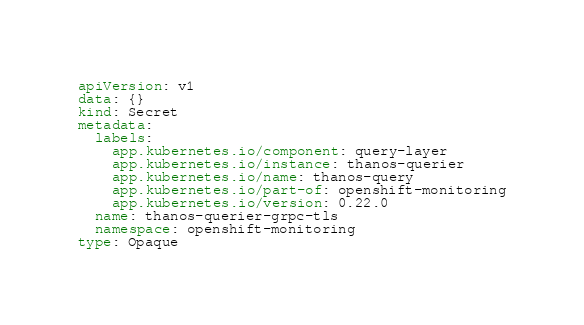<code> <loc_0><loc_0><loc_500><loc_500><_YAML_>apiVersion: v1
data: {}
kind: Secret
metadata:
  labels:
    app.kubernetes.io/component: query-layer
    app.kubernetes.io/instance: thanos-querier
    app.kubernetes.io/name: thanos-query
    app.kubernetes.io/part-of: openshift-monitoring
    app.kubernetes.io/version: 0.22.0
  name: thanos-querier-grpc-tls
  namespace: openshift-monitoring
type: Opaque
</code> 